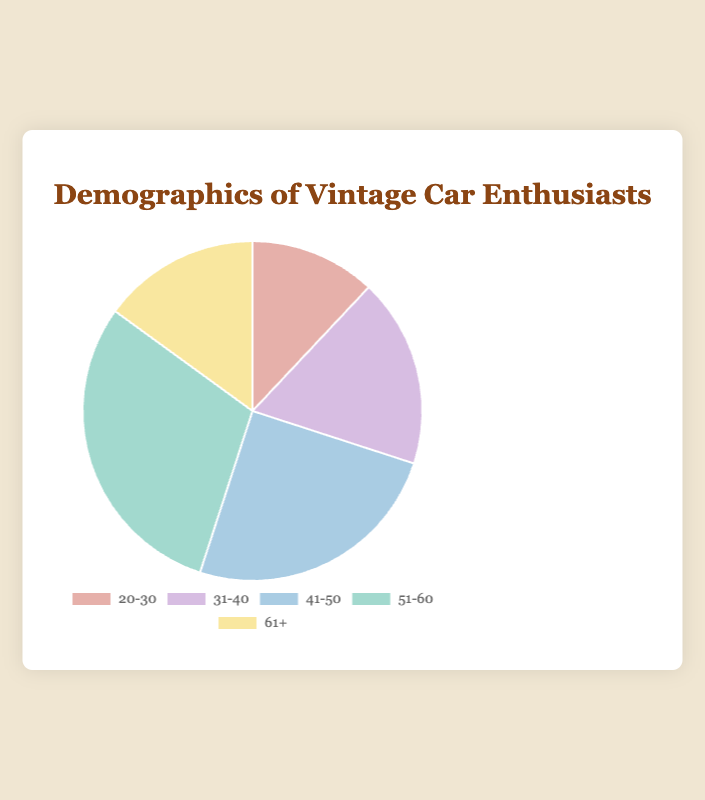What age group has the highest percentage of vintage car enthusiasts? The 51-60 age group has the highest percentage. By looking at the chart, this group has the largest segment, accounting for 30% of the enthusiasts.
Answer: 51-60 Which age group has a lower percentage of enthusiasts than the 41-50 group but more than the 20-30 group? The 61+ age group fits this criterion. The 41-50 group has 25%, the 61+ group has 15%, and the 20-30 group has 12%.
Answer: 61+ How do the percentages of the 31-40 and 61+ age groups compare? The 31-40 age group has 18%, while the 61+ age group has 15%. Therefore, the 31-40 group has a higher percentage than the 61+ group.
Answer: 31-40 has a higher percentage Calculate the combined percentage of vintage car enthusiasts in the 31-40 and 51-60 age groups. The percentage of the 31-40 age group is 18% and the 51-60 age group is 30%. Adding these together: 18% + 30% = 48%.
Answer: 48% What is the difference in percentage between the age groups with the highest and lowest values? The highest percentage is 30% (51-60 age group), and the lowest is 12% (20-30 age group). The difference is 30% - 12% = 18%.
Answer: 18% Which color represents the age group with the second-highest percentage? The second-highest percentage is 25% for the 41-50 age group. By observing the chart colors, this group is represented by blue.
Answer: Blue What is the average percentage of the age groups displayed in the chart? To find the average, sum the percentages (12% + 18% + 25% + 30% + 15% = 100%) and divide by the number of age groups (5). The average is 100% / 5 = 20%.
Answer: 20% Is the percentage of vintage car enthusiasts aged 61+ greater than the percentage of those aged 20-30? The percentage for the 61+ age group is 15%, whereas for the 20-30 age group it is 12%. Therefore, 15% is greater than 12%.
Answer: Yes What is the total percentage of vintage car enthusiasts aged 41 and above? Add the percentages of the 41-50, 51-60, and 61+ age groups: 25% + 30% + 15% = 70%.
Answer: 70% 